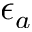<formula> <loc_0><loc_0><loc_500><loc_500>\epsilon _ { a }</formula> 